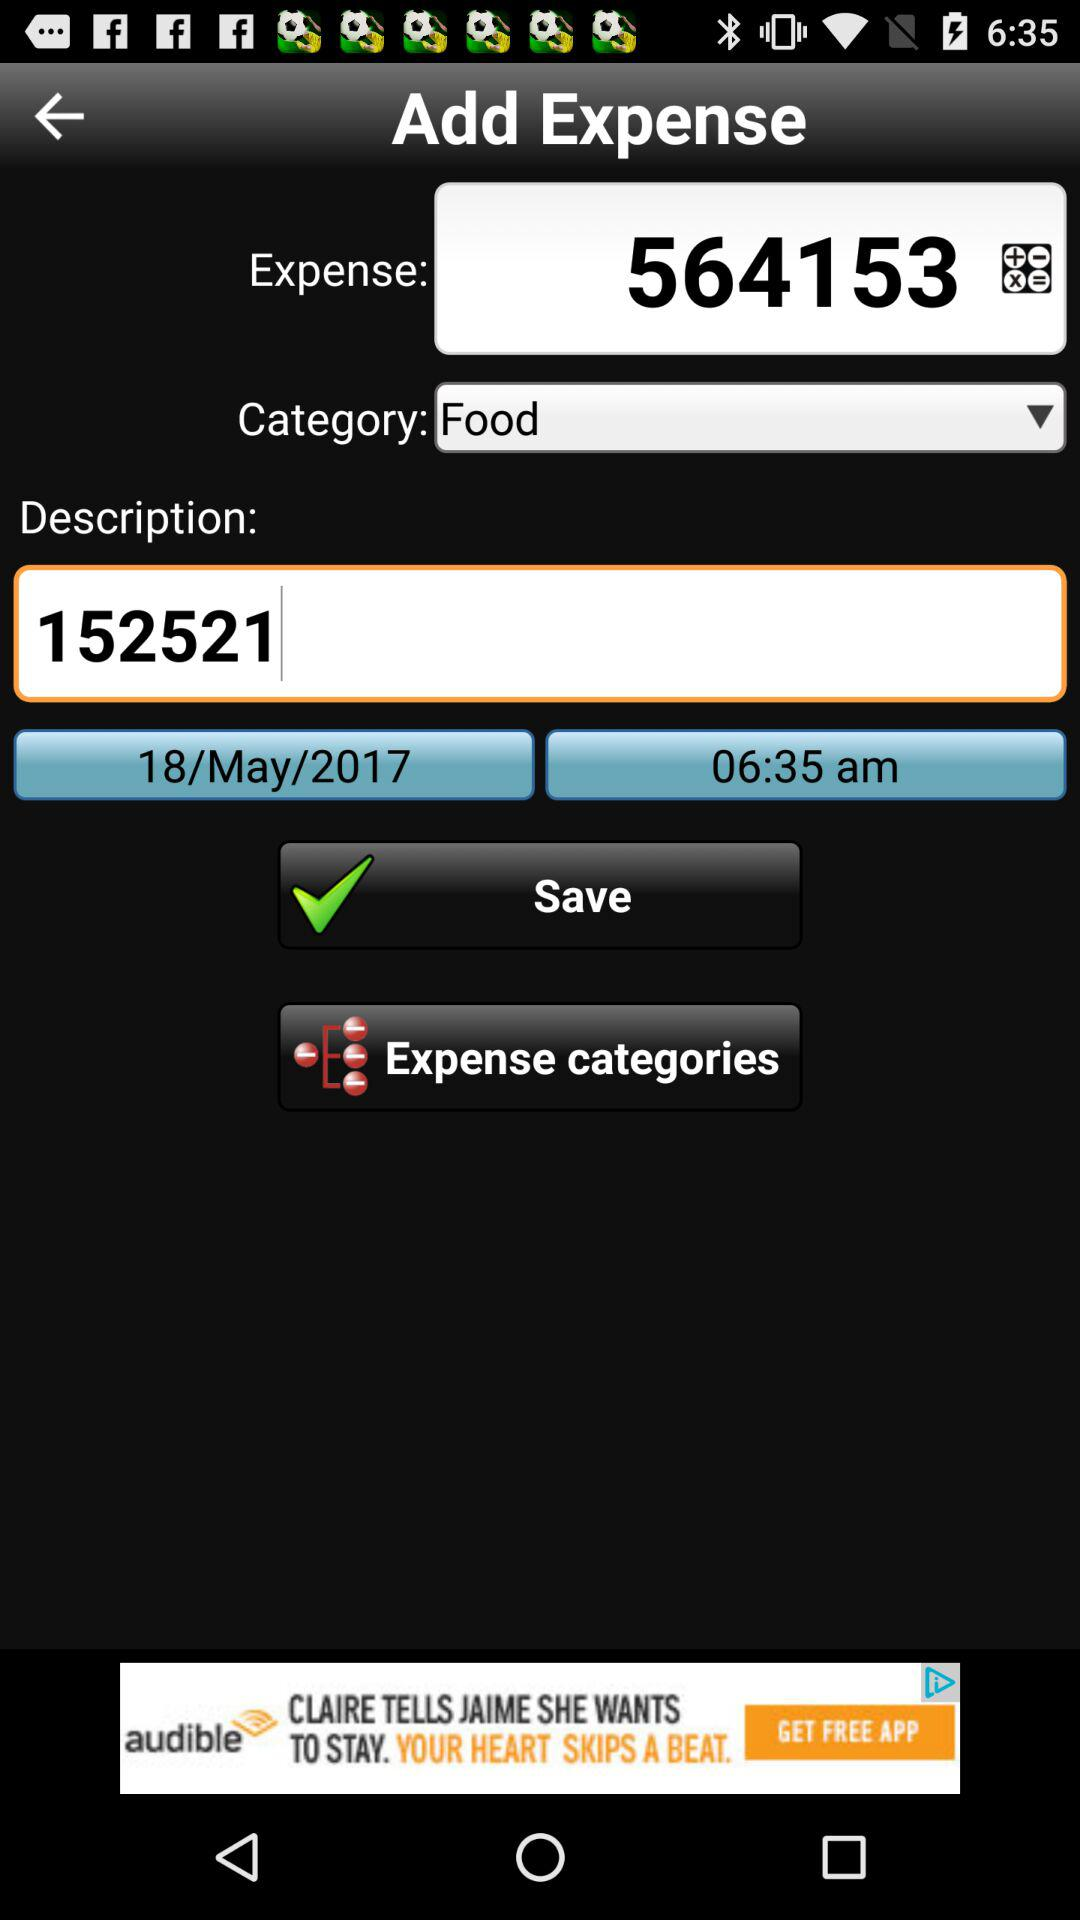How much is the expense?
Answer the question using a single word or phrase. 564153 